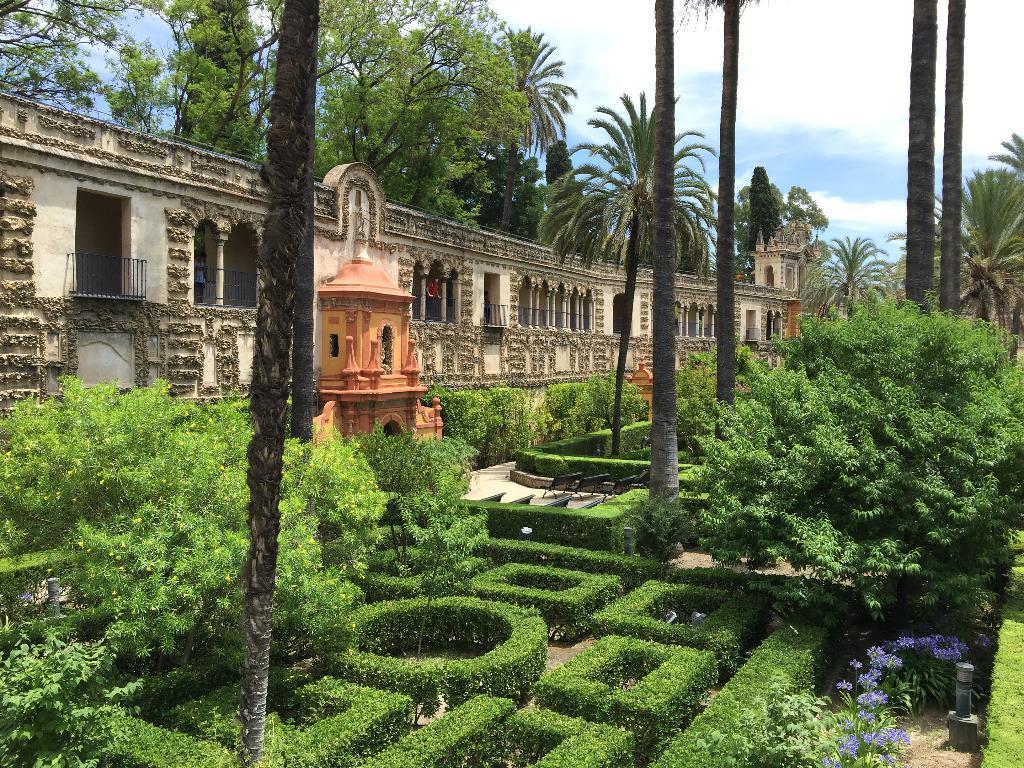How would you summarize this image in a sentence or two? In this image there is a sky, there are trees, there is a building, there are persons in the building, there are benches, there are flowers, there are plants. 